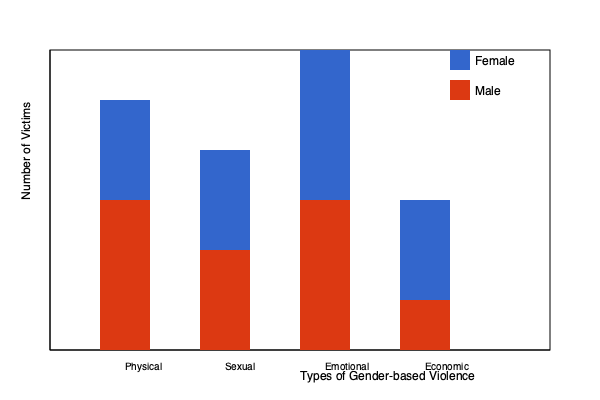Based on the stacked bar chart comparing male and female victims of different forms of gender-based violence, which type of violence shows the greatest disparity between female and male victims? To determine which type of violence shows the greatest disparity between female and male victims, we need to compare the differences in bar heights for each type of violence:

1. Physical violence:
   Female victims (blue): 250 units
   Male victims (red): 150 units
   Difference: 250 - 150 = 100 units

2. Sexual violence:
   Female victims: 200 units
   Male victims: 100 units
   Difference: 200 - 100 = 100 units

3. Emotional violence:
   Female victims: 300 units
   Male victims: 150 units
   Difference: 300 - 150 = 150 units

4. Economic violence:
   Female victims: 150 units
   Male victims: 50 units
   Difference: 150 - 50 = 100 units

The greatest disparity is observed in emotional violence, with a difference of 150 units between female and male victims.
Answer: Emotional violence 